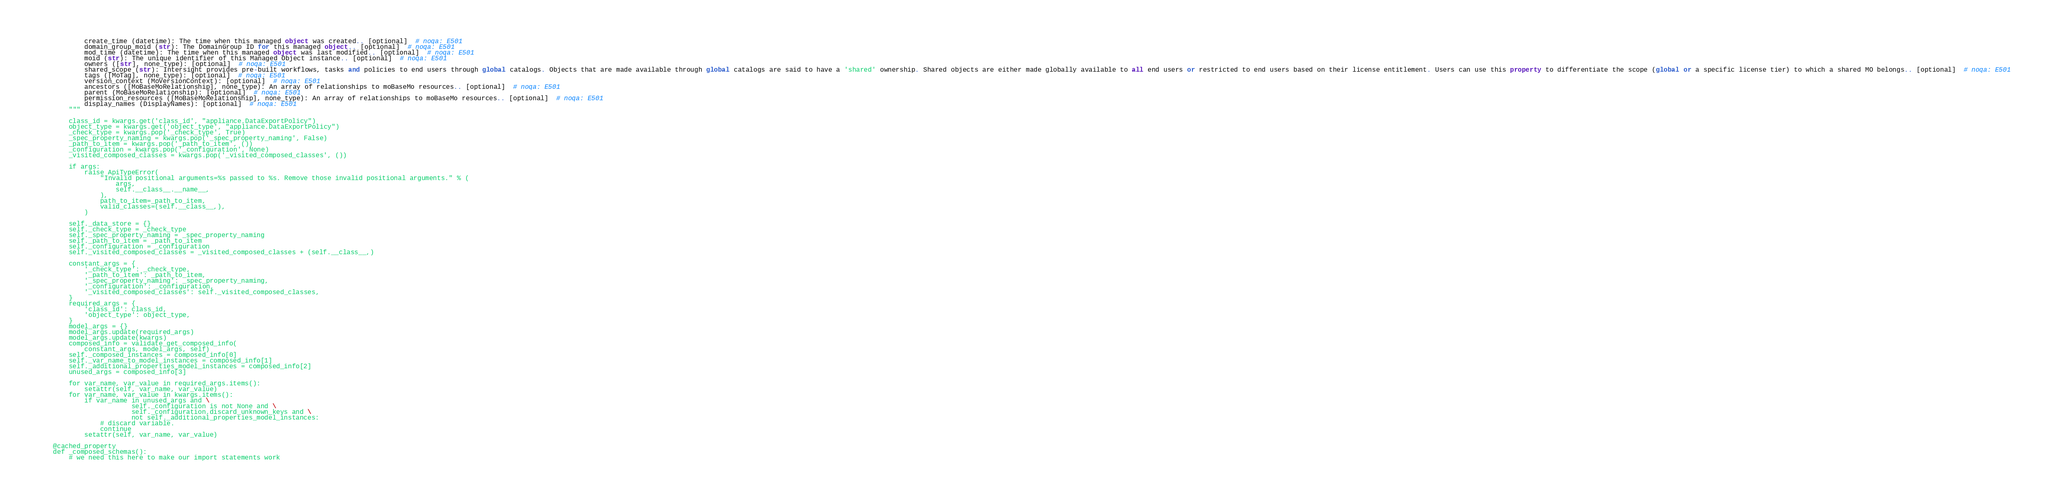Convert code to text. <code><loc_0><loc_0><loc_500><loc_500><_Python_>            create_time (datetime): The time when this managed object was created.. [optional]  # noqa: E501
            domain_group_moid (str): The DomainGroup ID for this managed object.. [optional]  # noqa: E501
            mod_time (datetime): The time when this managed object was last modified.. [optional]  # noqa: E501
            moid (str): The unique identifier of this Managed Object instance.. [optional]  # noqa: E501
            owners ([str], none_type): [optional]  # noqa: E501
            shared_scope (str): Intersight provides pre-built workflows, tasks and policies to end users through global catalogs. Objects that are made available through global catalogs are said to have a 'shared' ownership. Shared objects are either made globally available to all end users or restricted to end users based on their license entitlement. Users can use this property to differentiate the scope (global or a specific license tier) to which a shared MO belongs.. [optional]  # noqa: E501
            tags ([MoTag], none_type): [optional]  # noqa: E501
            version_context (MoVersionContext): [optional]  # noqa: E501
            ancestors ([MoBaseMoRelationship], none_type): An array of relationships to moBaseMo resources.. [optional]  # noqa: E501
            parent (MoBaseMoRelationship): [optional]  # noqa: E501
            permission_resources ([MoBaseMoRelationship], none_type): An array of relationships to moBaseMo resources.. [optional]  # noqa: E501
            display_names (DisplayNames): [optional]  # noqa: E501
        """

        class_id = kwargs.get('class_id', "appliance.DataExportPolicy")
        object_type = kwargs.get('object_type', "appliance.DataExportPolicy")
        _check_type = kwargs.pop('_check_type', True)
        _spec_property_naming = kwargs.pop('_spec_property_naming', False)
        _path_to_item = kwargs.pop('_path_to_item', ())
        _configuration = kwargs.pop('_configuration', None)
        _visited_composed_classes = kwargs.pop('_visited_composed_classes', ())

        if args:
            raise ApiTypeError(
                "Invalid positional arguments=%s passed to %s. Remove those invalid positional arguments." % (
                    args,
                    self.__class__.__name__,
                ),
                path_to_item=_path_to_item,
                valid_classes=(self.__class__,),
            )

        self._data_store = {}
        self._check_type = _check_type
        self._spec_property_naming = _spec_property_naming
        self._path_to_item = _path_to_item
        self._configuration = _configuration
        self._visited_composed_classes = _visited_composed_classes + (self.__class__,)

        constant_args = {
            '_check_type': _check_type,
            '_path_to_item': _path_to_item,
            '_spec_property_naming': _spec_property_naming,
            '_configuration': _configuration,
            '_visited_composed_classes': self._visited_composed_classes,
        }
        required_args = {
            'class_id': class_id,
            'object_type': object_type,
        }
        model_args = {}
        model_args.update(required_args)
        model_args.update(kwargs)
        composed_info = validate_get_composed_info(
            constant_args, model_args, self)
        self._composed_instances = composed_info[0]
        self._var_name_to_model_instances = composed_info[1]
        self._additional_properties_model_instances = composed_info[2]
        unused_args = composed_info[3]

        for var_name, var_value in required_args.items():
            setattr(self, var_name, var_value)
        for var_name, var_value in kwargs.items():
            if var_name in unused_args and \
                        self._configuration is not None and \
                        self._configuration.discard_unknown_keys and \
                        not self._additional_properties_model_instances:
                # discard variable.
                continue
            setattr(self, var_name, var_value)

    @cached_property
    def _composed_schemas():
        # we need this here to make our import statements work</code> 